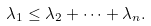<formula> <loc_0><loc_0><loc_500><loc_500>\lambda _ { 1 } \leq \lambda _ { 2 } + \cdots + \lambda _ { n } .</formula> 